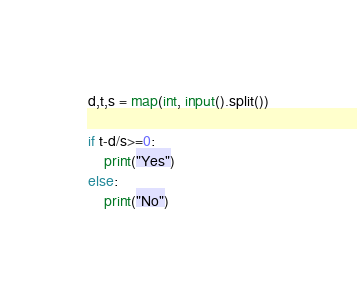Convert code to text. <code><loc_0><loc_0><loc_500><loc_500><_Python_>d,t,s = map(int, input().split())

if t-d/s>=0:
    print("Yes")
else:
    print("No")</code> 